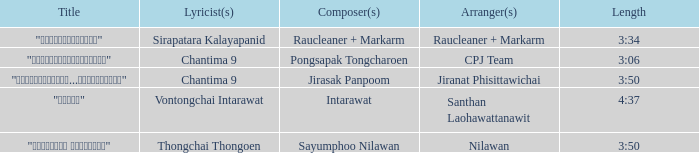Who was the composer of "ขอโทษ"? Intarawat. 